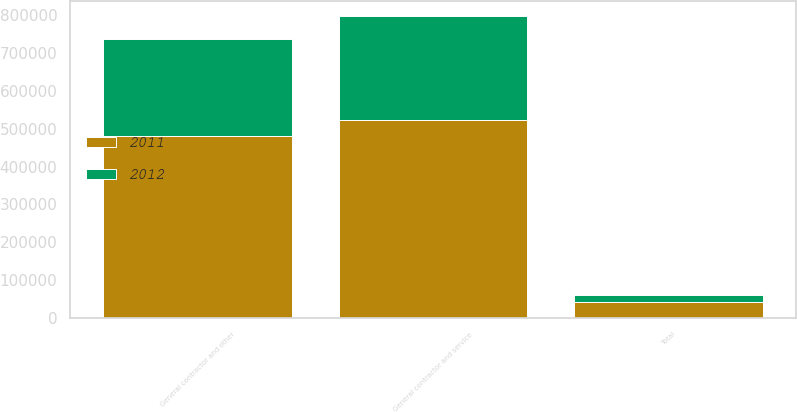Convert chart to OTSL. <chart><loc_0><loc_0><loc_500><loc_500><stacked_bar_chart><ecel><fcel>General contractor and service<fcel>General contractor and other<fcel>Total<nl><fcel>2012<fcel>275071<fcel>254870<fcel>20201<nl><fcel>2011<fcel>521796<fcel>480480<fcel>41316<nl></chart> 